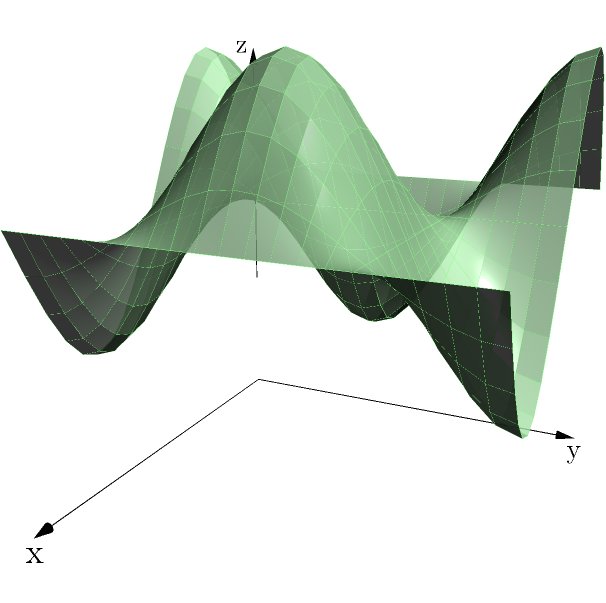As part of your efforts to hold a mining company accountable, you need to estimate the volume of their tailings pile. The 3D model of the tailings pile is represented by the function $z = 4 + 2\sin(2x)\cos(y)$ over the region $0 \leq x \leq \pi$ and $0 \leq y \leq 2\pi$. Calculate the volume of the tailings pile using triple integration. To calculate the volume of the tailings pile, we need to use triple integration. Here's the step-by-step process:

1) The volume is given by the triple integral:
   $$V = \iiint_V dV = \int_0^\pi \int_0^{2\pi} \int_0^{4+2\sin(2x)\cos(y)} dz \, dy \, dx$$

2) First, integrate with respect to z:
   $$V = \int_0^\pi \int_0^{2\pi} [z]_0^{4+2\sin(2x)\cos(y)} dy \, dx$$
   $$V = \int_0^\pi \int_0^{2\pi} (4+2\sin(2x)\cos(y)) dy \, dx$$

3) Now, integrate with respect to y:
   $$V = \int_0^\pi \left[4y + 2\sin(2x)\sin(y)\right]_0^{2\pi} dx$$
   $$V = \int_0^\pi (8\pi + 0) dx = 8\pi \int_0^\pi dx$$

4) Finally, integrate with respect to x:
   $$V = 8\pi [\pi]_0^\pi = 8\pi^2$$

Therefore, the volume of the tailings pile is $8\pi^2$ cubic units.
Answer: $8\pi^2$ cubic units 